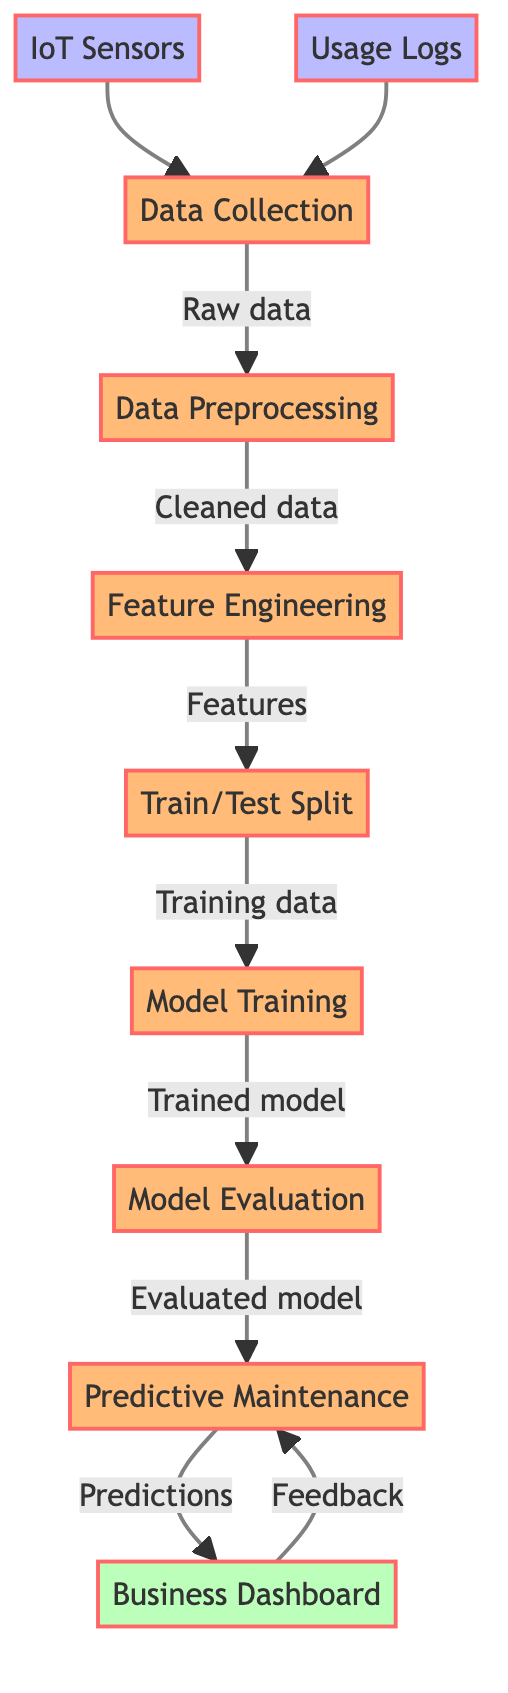What are the two inputs to the data collection process? The diagram shows two arrows leading into the "Data Collection" node from the "IoT Sensors" and "Usage Logs" nodes, indicating that these are the inputs required for this process.
Answer: IoT Sensors, Usage Logs What is the output of data preprocessing? According to the diagram, the output from the "Data Preprocessing" node is labeled as "Cleaned data," which indicates what comes after preprocessing the raw data.
Answer: Cleaned data How many processes are depicted in the diagram? By counting the nodes that represent processes, we can see there are six nodes labeled as processes: Data Collection, Data Preprocessing, Feature Engineering, Train/Test Split, Model Training, Model Evaluation, and Predictive Maintenance.
Answer: Six Which process comes directly after feature engineering? The flow of the diagram shows that "Train/Test Split" follows "Feature Engineering," as the arrow points from feature engineering to train/test split indicating the sequence of these processes.
Answer: Train/Test Split What type of feedback is shown in the diagram? The diagram indicates that the "Business Dashboard" node provides "Feedback" to the "Predictive Maintenance" process, signifying that the results or predictions from the maintenance process are evaluated or used for further insights.
Answer: Feedback What is the final output of the predictive maintenance process? The "Predictive Maintenance" node leads to the "Business Dashboard" node with the label "Predictions," which indicates that the predictions made by the predictive maintenance are what this process outputs.
Answer: Predictions Which node handles the feature extraction process? The "Feature Engineering" node is identified in the diagram as the step responsible for extracting and selecting features from the cleaned data collected in the prior steps.
Answer: Feature Engineering How does the model evaluation connect to predictive maintenance? The "Model Evaluation" node leads directly to the "Predictive Maintenance" node, which indicates that the output from the model evaluation informs the predictions made during the maintenance process.
Answer: Directly connected 